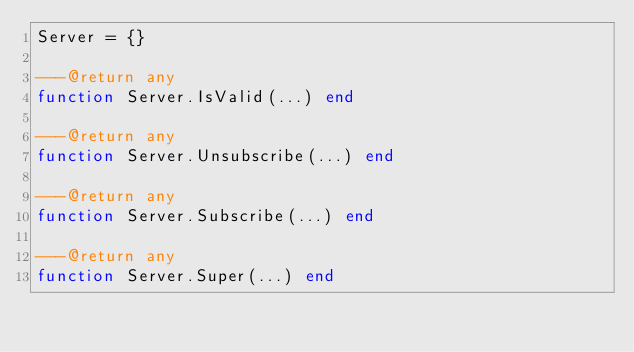Convert code to text. <code><loc_0><loc_0><loc_500><loc_500><_Lua_>Server = {}

---@return any
function Server.IsValid(...) end

---@return any
function Server.Unsubscribe(...) end

---@return any
function Server.Subscribe(...) end

---@return any
function Server.Super(...) end

</code> 